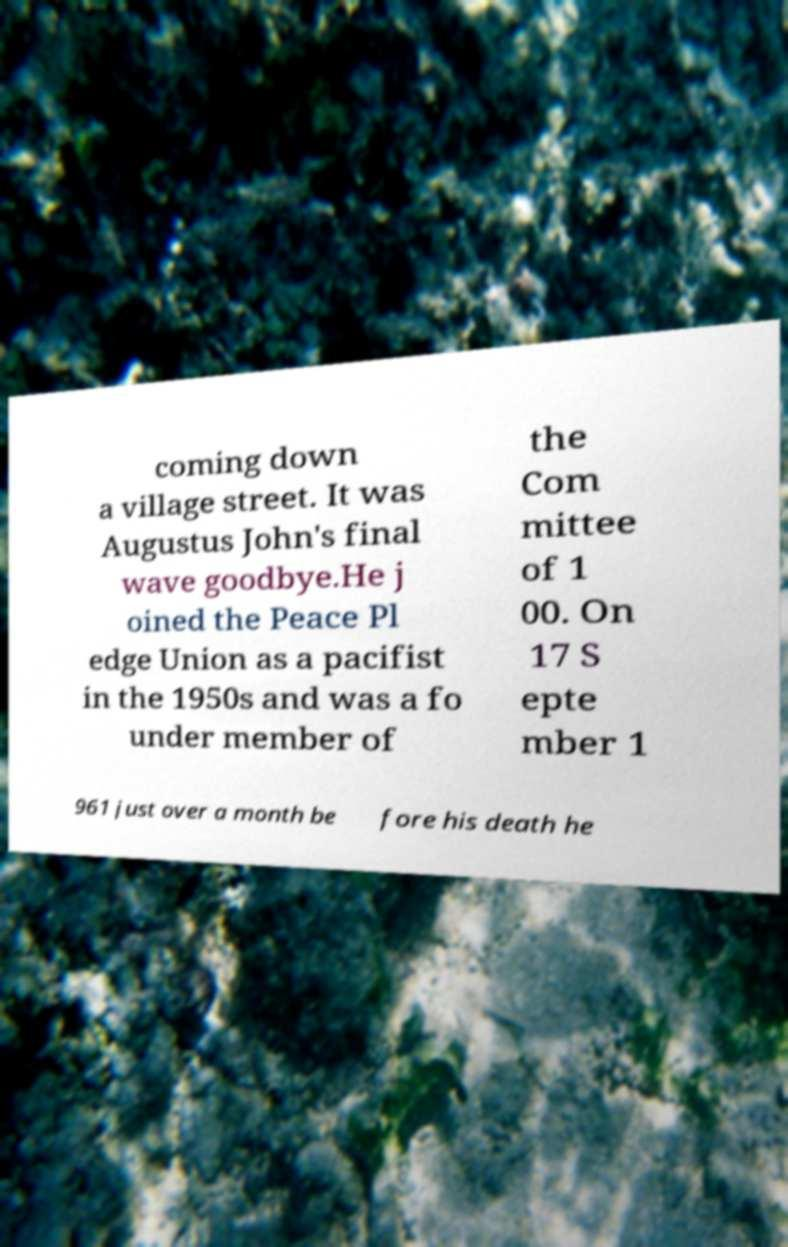Could you assist in decoding the text presented in this image and type it out clearly? coming down a village street. It was Augustus John's final wave goodbye.He j oined the Peace Pl edge Union as a pacifist in the 1950s and was a fo under member of the Com mittee of 1 00. On 17 S epte mber 1 961 just over a month be fore his death he 